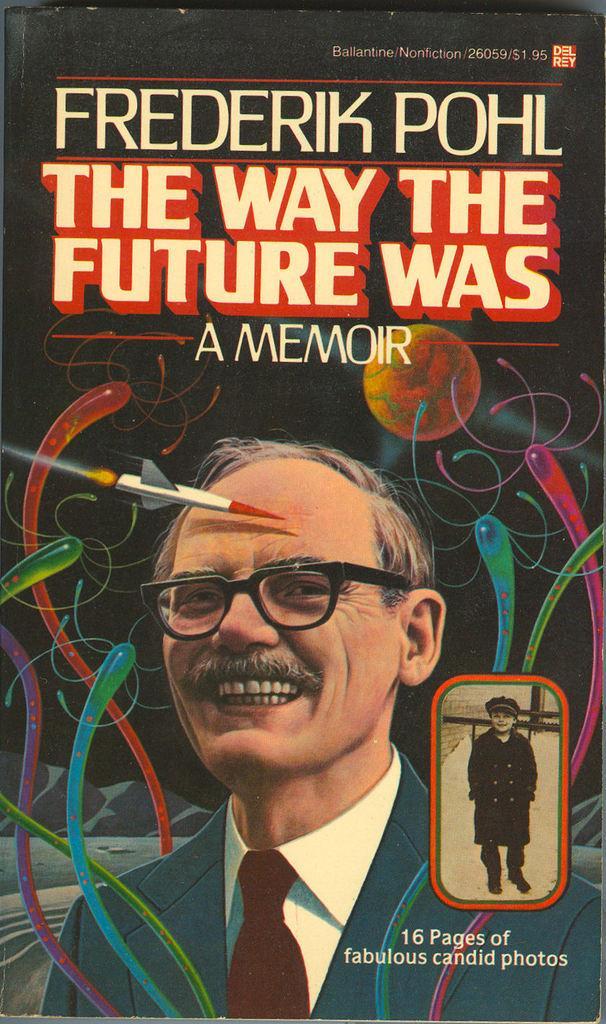Please provide a concise description of this image. In this picture I can see there is a man standing, he is wearing a blazer, shirt, tie and he is laughing, there is another picture of a person at right side and there is something written on it. This is a cover page of a book. 